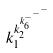<formula> <loc_0><loc_0><loc_500><loc_500>k _ { 1 } ^ { k _ { 2 } ^ { k _ { 6 } ^ { - ^ { - ^ { - } } } } }</formula> 